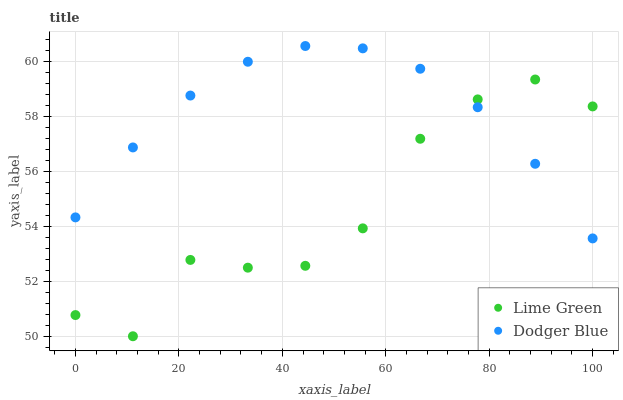Does Lime Green have the minimum area under the curve?
Answer yes or no. Yes. Does Dodger Blue have the maximum area under the curve?
Answer yes or no. Yes. Does Lime Green have the maximum area under the curve?
Answer yes or no. No. Is Dodger Blue the smoothest?
Answer yes or no. Yes. Is Lime Green the roughest?
Answer yes or no. Yes. Is Lime Green the smoothest?
Answer yes or no. No. Does Lime Green have the lowest value?
Answer yes or no. Yes. Does Dodger Blue have the highest value?
Answer yes or no. Yes. Does Lime Green have the highest value?
Answer yes or no. No. Does Lime Green intersect Dodger Blue?
Answer yes or no. Yes. Is Lime Green less than Dodger Blue?
Answer yes or no. No. Is Lime Green greater than Dodger Blue?
Answer yes or no. No. 